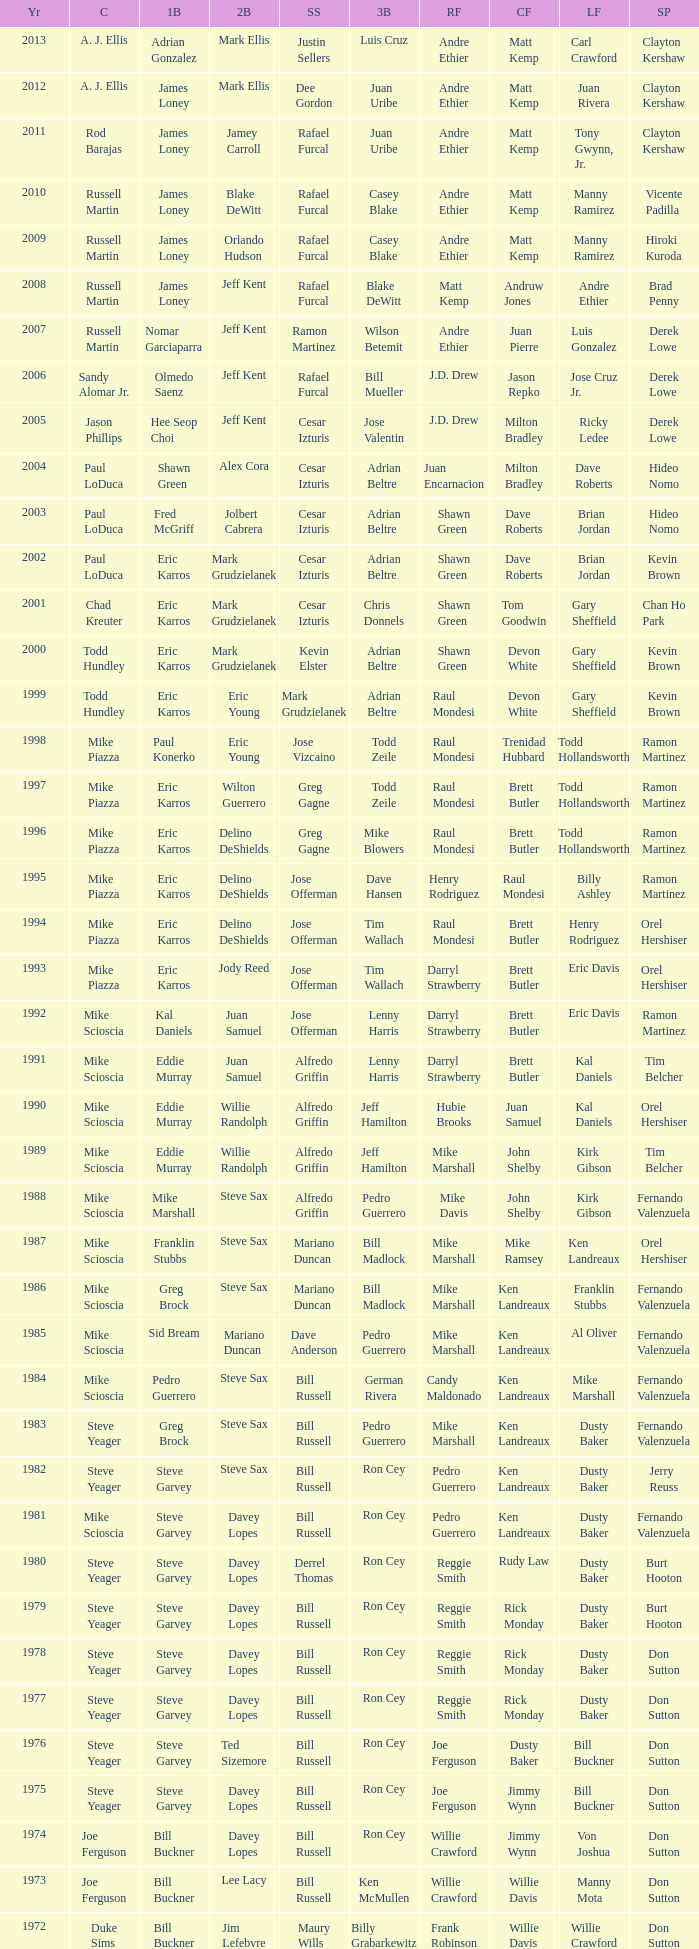Who played SS when paul konerko played 1st base? Jose Vizcaino. 